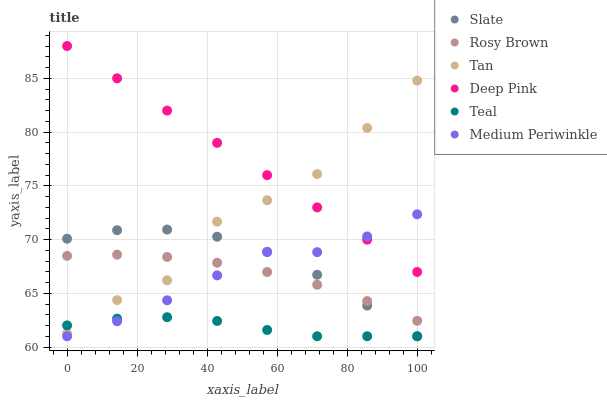Does Teal have the minimum area under the curve?
Answer yes or no. Yes. Does Deep Pink have the maximum area under the curve?
Answer yes or no. Yes. Does Slate have the minimum area under the curve?
Answer yes or no. No. Does Slate have the maximum area under the curve?
Answer yes or no. No. Is Deep Pink the smoothest?
Answer yes or no. Yes. Is Tan the roughest?
Answer yes or no. Yes. Is Slate the smoothest?
Answer yes or no. No. Is Slate the roughest?
Answer yes or no. No. Does Slate have the lowest value?
Answer yes or no. Yes. Does Rosy Brown have the lowest value?
Answer yes or no. No. Does Deep Pink have the highest value?
Answer yes or no. Yes. Does Slate have the highest value?
Answer yes or no. No. Is Teal less than Deep Pink?
Answer yes or no. Yes. Is Deep Pink greater than Teal?
Answer yes or no. Yes. Does Slate intersect Tan?
Answer yes or no. Yes. Is Slate less than Tan?
Answer yes or no. No. Is Slate greater than Tan?
Answer yes or no. No. Does Teal intersect Deep Pink?
Answer yes or no. No. 